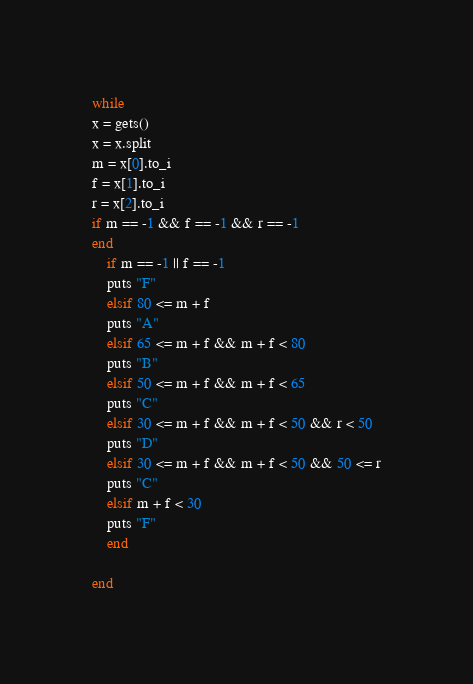<code> <loc_0><loc_0><loc_500><loc_500><_Ruby_>while
x = gets()
x = x.split
m = x[0].to_i
f = x[1].to_i 
r = x[2].to_i
if m == -1 && f == -1 && r == -1
end
    if m == -1 || f == -1
    puts "F"
    elsif 80 <= m + f
    puts "A"
    elsif 65 <= m + f && m + f < 80
    puts "B"
    elsif 50 <= m + f && m + f < 65
    puts "C"
    elsif 30 <= m + f && m + f < 50 && r < 50
    puts "D"
    elsif 30 <= m + f && m + f < 50 && 50 <= r
    puts "C"
    elsif m + f < 30
    puts "F"
    end
    
end

</code> 